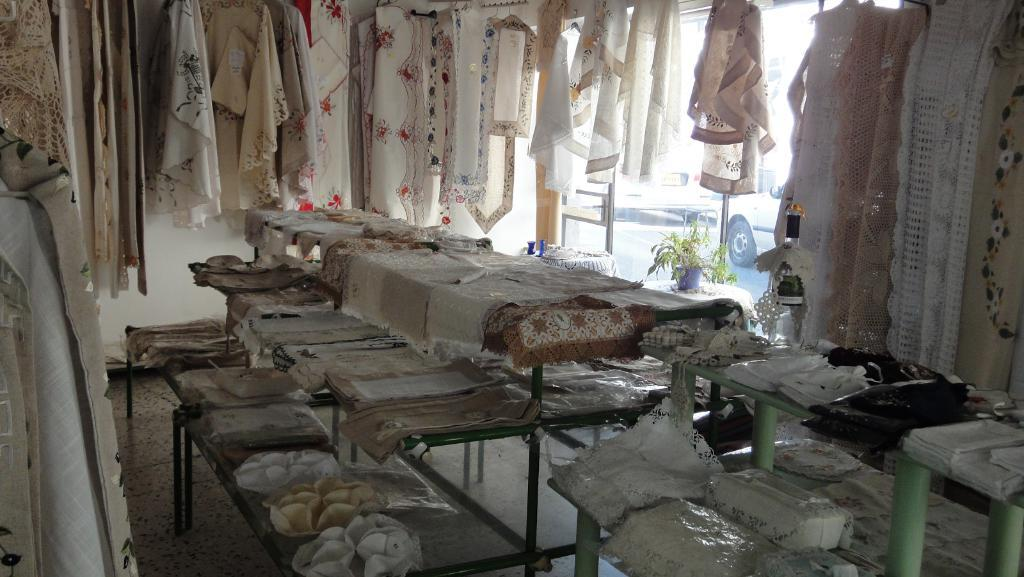What is being displayed on the table in the image? There are clothes hanged and kept on the table in the image. What can be seen beneath the table? There is a floor visible in the image. What is located to the right of the image? There is a door to the right of the image. What is visible through the door in the image? Cars are visible through the door in the image. Can you see a scarecrow in the plantation through the door in the image? There is no plantation or scarecrow present in the image. The door shows a view of cars, not a plantation. 